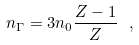Convert formula to latex. <formula><loc_0><loc_0><loc_500><loc_500>n _ { \Gamma } = 3 n _ { 0 } \frac { Z - 1 } { Z } \ ,</formula> 